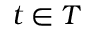<formula> <loc_0><loc_0><loc_500><loc_500>t \in T</formula> 